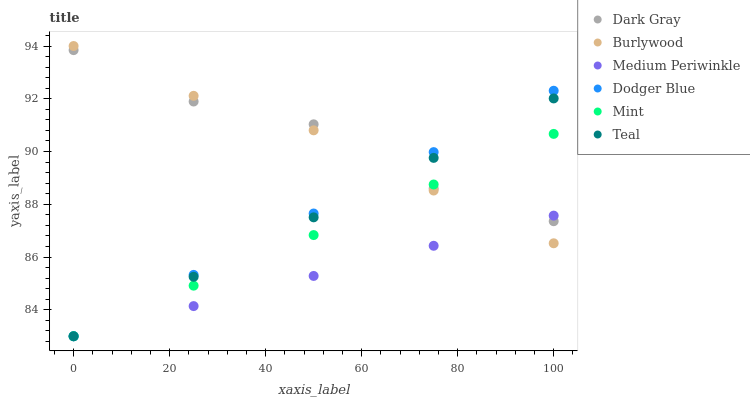Does Medium Periwinkle have the minimum area under the curve?
Answer yes or no. Yes. Does Dark Gray have the maximum area under the curve?
Answer yes or no. Yes. Does Dark Gray have the minimum area under the curve?
Answer yes or no. No. Does Medium Periwinkle have the maximum area under the curve?
Answer yes or no. No. Is Teal the smoothest?
Answer yes or no. Yes. Is Dark Gray the roughest?
Answer yes or no. Yes. Is Medium Periwinkle the smoothest?
Answer yes or no. No. Is Medium Periwinkle the roughest?
Answer yes or no. No. Does Medium Periwinkle have the lowest value?
Answer yes or no. Yes. Does Dark Gray have the lowest value?
Answer yes or no. No. Does Burlywood have the highest value?
Answer yes or no. Yes. Does Dark Gray have the highest value?
Answer yes or no. No. Does Mint intersect Medium Periwinkle?
Answer yes or no. Yes. Is Mint less than Medium Periwinkle?
Answer yes or no. No. Is Mint greater than Medium Periwinkle?
Answer yes or no. No. 